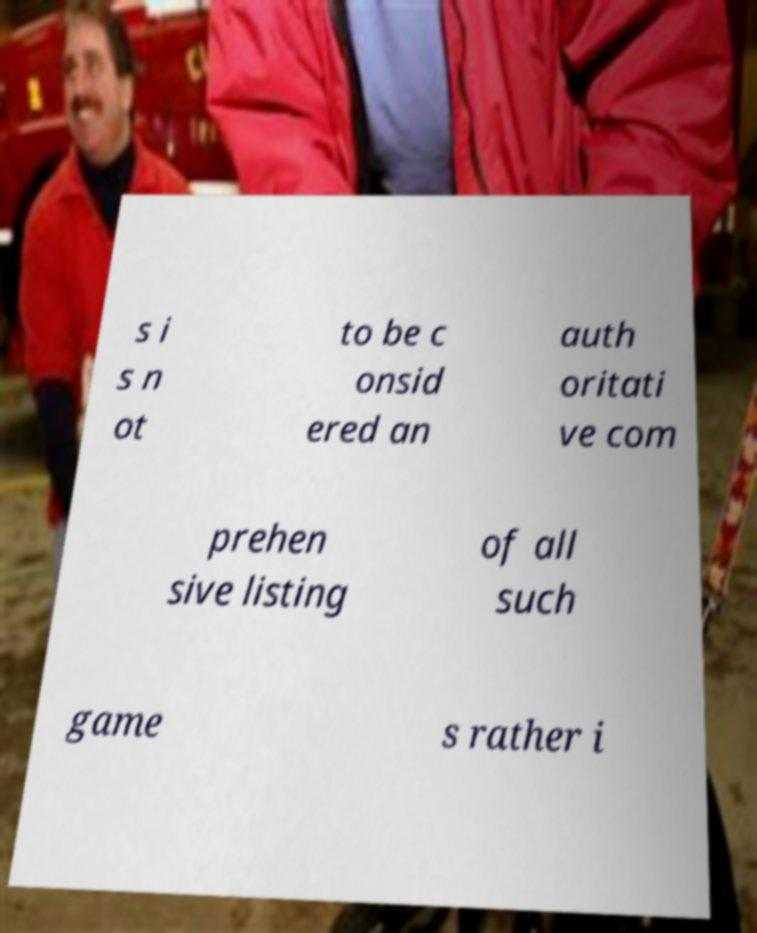Can you read and provide the text displayed in the image?This photo seems to have some interesting text. Can you extract and type it out for me? s i s n ot to be c onsid ered an auth oritati ve com prehen sive listing of all such game s rather i 